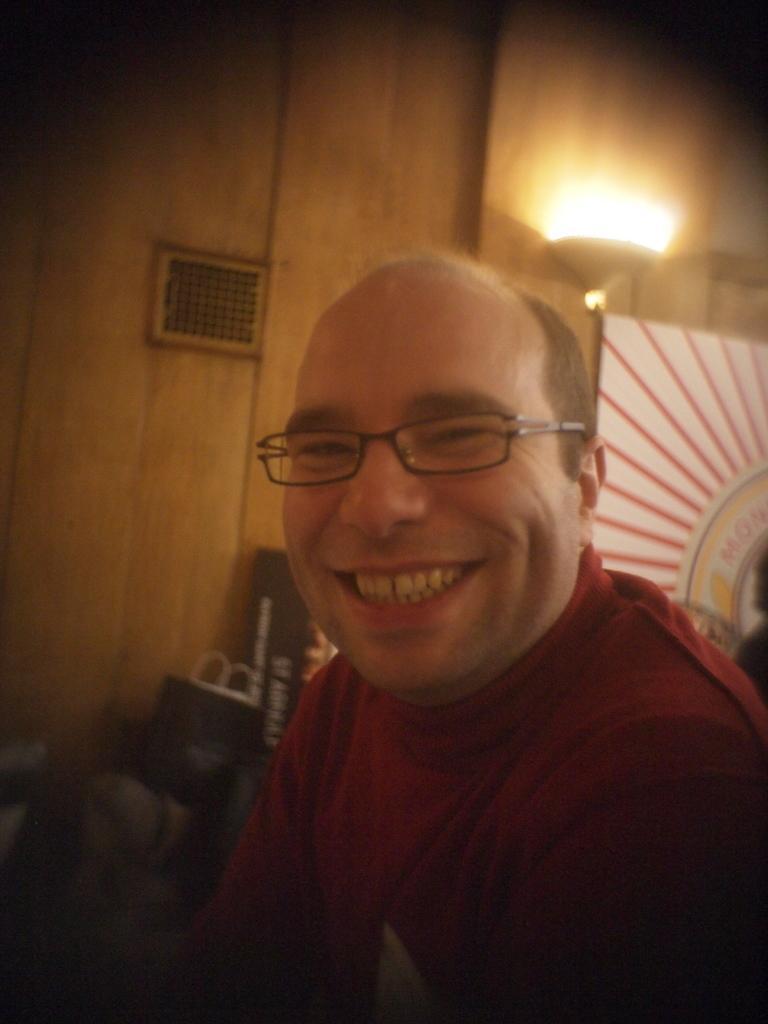Can you describe this image briefly? In the background we can see the wall, grille, light, board, carry bag and few objects. On the right side of the picture we can see a man wearing a t-shirt and spectacles. He is smiling. 